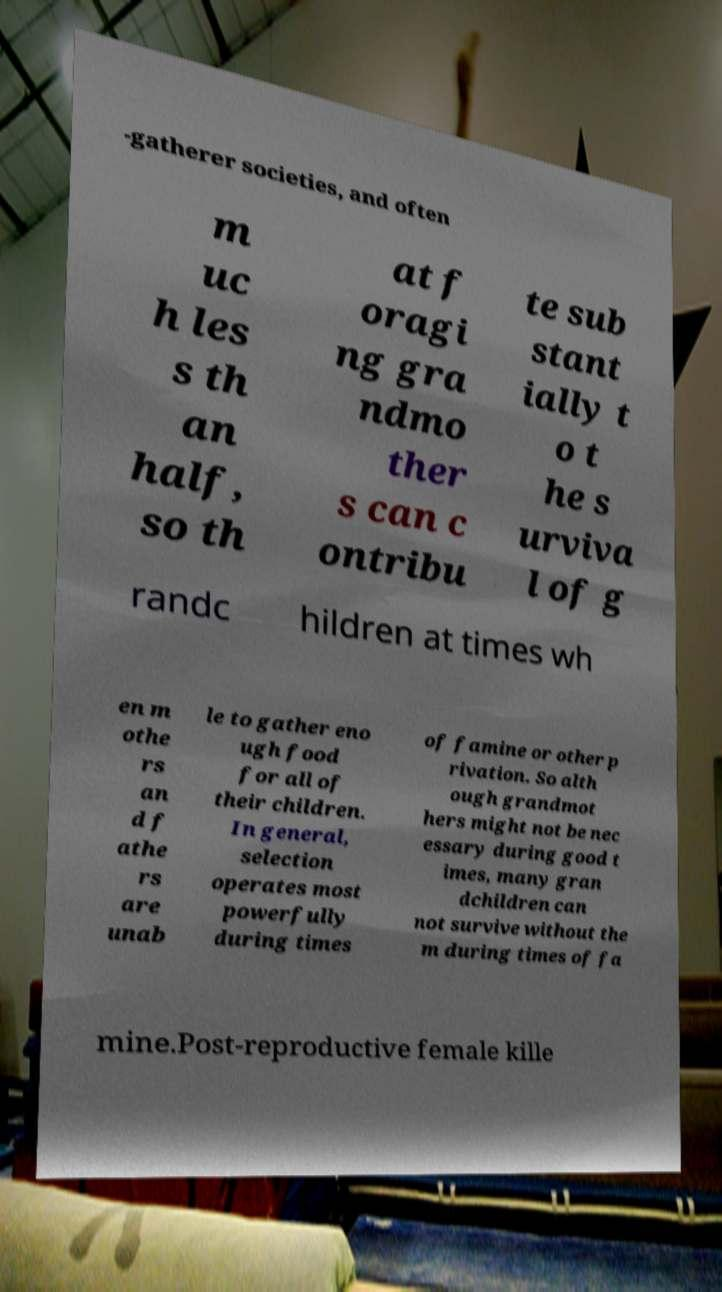Can you accurately transcribe the text from the provided image for me? -gatherer societies, and often m uc h les s th an half, so th at f oragi ng gra ndmo ther s can c ontribu te sub stant ially t o t he s urviva l of g randc hildren at times wh en m othe rs an d f athe rs are unab le to gather eno ugh food for all of their children. In general, selection operates most powerfully during times of famine or other p rivation. So alth ough grandmot hers might not be nec essary during good t imes, many gran dchildren can not survive without the m during times of fa mine.Post-reproductive female kille 